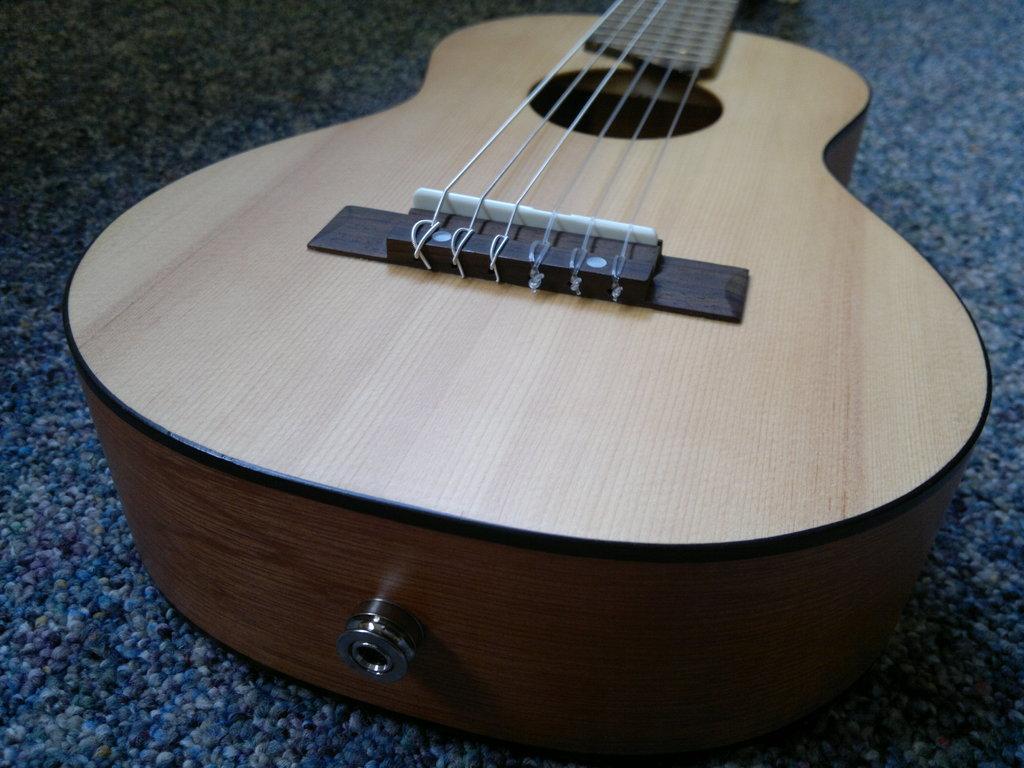Can you describe this image briefly? This is a guitar. 